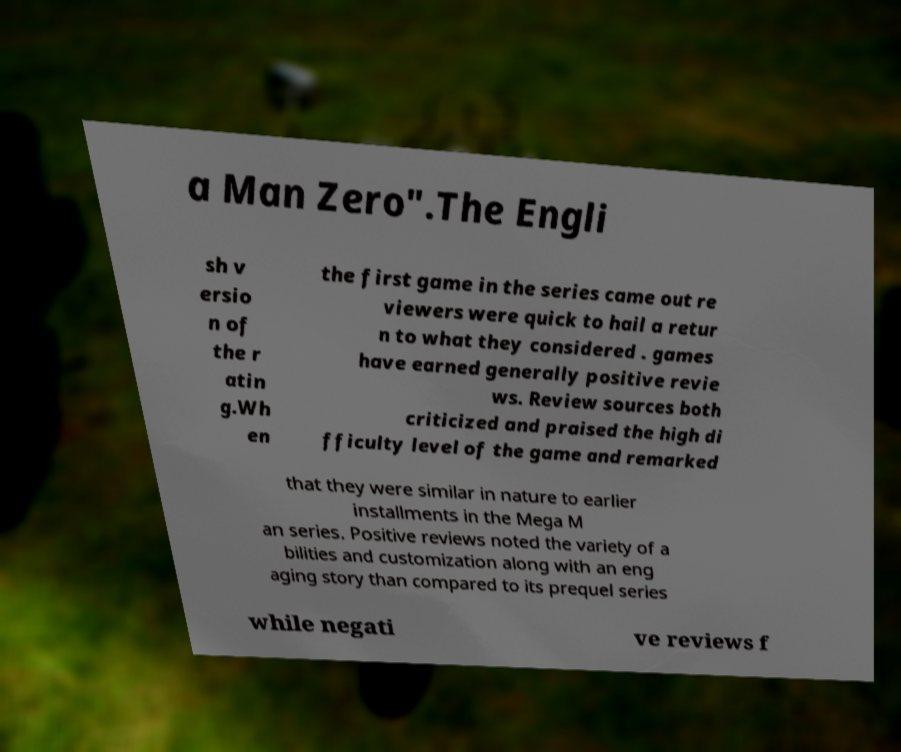Can you accurately transcribe the text from the provided image for me? a Man Zero".The Engli sh v ersio n of the r atin g.Wh en the first game in the series came out re viewers were quick to hail a retur n to what they considered . games have earned generally positive revie ws. Review sources both criticized and praised the high di fficulty level of the game and remarked that they were similar in nature to earlier installments in the Mega M an series. Positive reviews noted the variety of a bilities and customization along with an eng aging story than compared to its prequel series while negati ve reviews f 